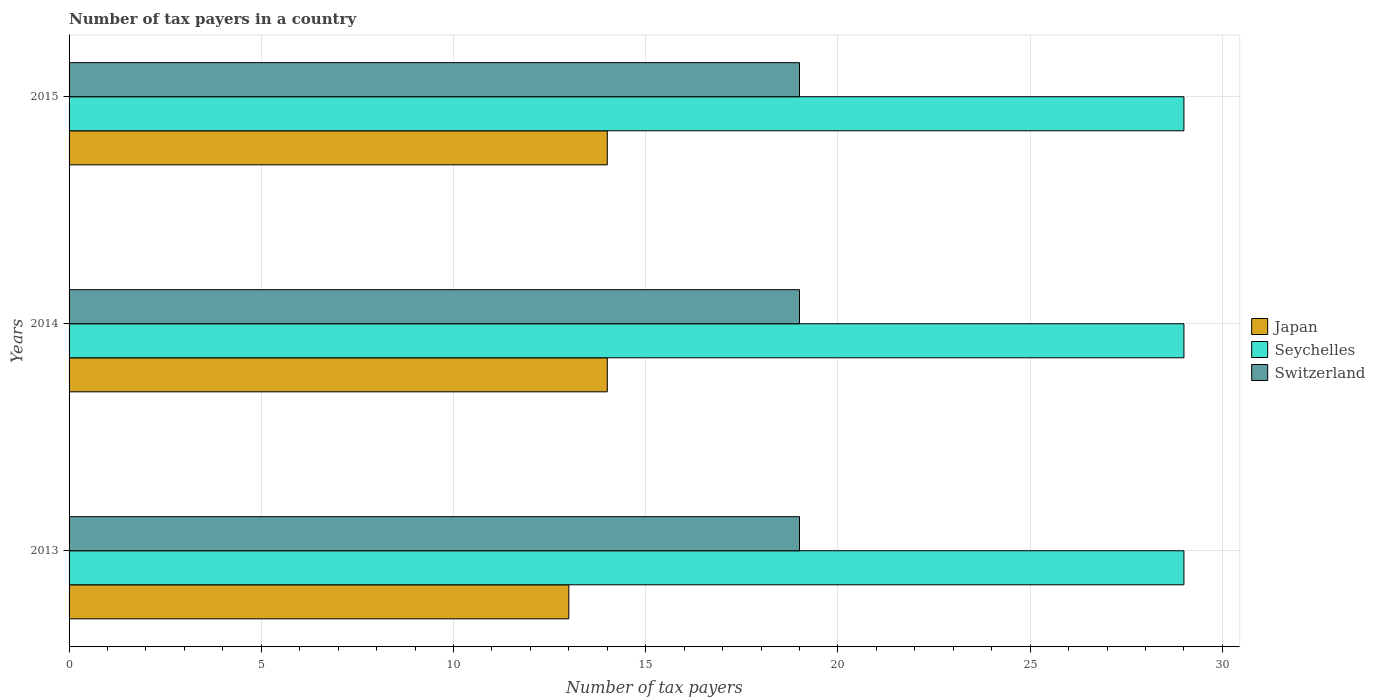Are the number of bars on each tick of the Y-axis equal?
Offer a very short reply. Yes. How many bars are there on the 2nd tick from the top?
Keep it short and to the point. 3. What is the label of the 3rd group of bars from the top?
Keep it short and to the point. 2013. What is the number of tax payers in in Switzerland in 2014?
Ensure brevity in your answer.  19. Across all years, what is the maximum number of tax payers in in Seychelles?
Provide a short and direct response. 29. Across all years, what is the minimum number of tax payers in in Japan?
Make the answer very short. 13. In which year was the number of tax payers in in Seychelles maximum?
Keep it short and to the point. 2013. What is the total number of tax payers in in Switzerland in the graph?
Offer a very short reply. 57. What is the difference between the number of tax payers in in Seychelles in 2013 and that in 2014?
Offer a terse response. 0. What is the difference between the number of tax payers in in Japan in 2013 and the number of tax payers in in Switzerland in 2015?
Keep it short and to the point. -6. What is the average number of tax payers in in Japan per year?
Your answer should be compact. 13.67. In how many years, is the number of tax payers in in Seychelles greater than 16 ?
Give a very brief answer. 3. What is the ratio of the number of tax payers in in Switzerland in 2013 to that in 2014?
Your answer should be very brief. 1. Is the number of tax payers in in Switzerland in 2013 less than that in 2014?
Provide a short and direct response. No. In how many years, is the number of tax payers in in Seychelles greater than the average number of tax payers in in Seychelles taken over all years?
Give a very brief answer. 0. What does the 1st bar from the top in 2014 represents?
Give a very brief answer. Switzerland. What does the 3rd bar from the bottom in 2014 represents?
Your response must be concise. Switzerland. Are all the bars in the graph horizontal?
Offer a very short reply. Yes. How many years are there in the graph?
Give a very brief answer. 3. Are the values on the major ticks of X-axis written in scientific E-notation?
Ensure brevity in your answer.  No. Does the graph contain any zero values?
Your answer should be very brief. No. Does the graph contain grids?
Provide a short and direct response. Yes. Where does the legend appear in the graph?
Your answer should be compact. Center right. How many legend labels are there?
Your response must be concise. 3. How are the legend labels stacked?
Offer a terse response. Vertical. What is the title of the graph?
Keep it short and to the point. Number of tax payers in a country. What is the label or title of the X-axis?
Offer a very short reply. Number of tax payers. What is the Number of tax payers of Japan in 2013?
Your answer should be compact. 13. What is the Number of tax payers of Japan in 2014?
Provide a short and direct response. 14. What is the Number of tax payers in Seychelles in 2014?
Ensure brevity in your answer.  29. Across all years, what is the maximum Number of tax payers of Seychelles?
Keep it short and to the point. 29. Across all years, what is the maximum Number of tax payers in Switzerland?
Provide a succinct answer. 19. Across all years, what is the minimum Number of tax payers of Seychelles?
Offer a terse response. 29. Across all years, what is the minimum Number of tax payers of Switzerland?
Keep it short and to the point. 19. What is the total Number of tax payers in Seychelles in the graph?
Make the answer very short. 87. What is the total Number of tax payers of Switzerland in the graph?
Ensure brevity in your answer.  57. What is the difference between the Number of tax payers in Japan in 2013 and that in 2014?
Offer a terse response. -1. What is the difference between the Number of tax payers in Switzerland in 2013 and that in 2014?
Your response must be concise. 0. What is the difference between the Number of tax payers of Seychelles in 2013 and that in 2015?
Give a very brief answer. 0. What is the difference between the Number of tax payers in Japan in 2013 and the Number of tax payers in Switzerland in 2014?
Make the answer very short. -6. What is the difference between the Number of tax payers in Japan in 2013 and the Number of tax payers in Seychelles in 2015?
Ensure brevity in your answer.  -16. What is the difference between the Number of tax payers in Japan in 2013 and the Number of tax payers in Switzerland in 2015?
Ensure brevity in your answer.  -6. What is the difference between the Number of tax payers in Japan in 2014 and the Number of tax payers in Seychelles in 2015?
Keep it short and to the point. -15. What is the difference between the Number of tax payers in Japan in 2014 and the Number of tax payers in Switzerland in 2015?
Your answer should be compact. -5. What is the difference between the Number of tax payers in Seychelles in 2014 and the Number of tax payers in Switzerland in 2015?
Your answer should be compact. 10. What is the average Number of tax payers of Japan per year?
Your answer should be compact. 13.67. What is the average Number of tax payers in Seychelles per year?
Keep it short and to the point. 29. In the year 2013, what is the difference between the Number of tax payers in Japan and Number of tax payers in Switzerland?
Provide a short and direct response. -6. In the year 2013, what is the difference between the Number of tax payers of Seychelles and Number of tax payers of Switzerland?
Your answer should be compact. 10. In the year 2014, what is the difference between the Number of tax payers in Japan and Number of tax payers in Seychelles?
Provide a short and direct response. -15. In the year 2014, what is the difference between the Number of tax payers of Japan and Number of tax payers of Switzerland?
Make the answer very short. -5. In the year 2015, what is the difference between the Number of tax payers in Japan and Number of tax payers in Switzerland?
Offer a very short reply. -5. In the year 2015, what is the difference between the Number of tax payers of Seychelles and Number of tax payers of Switzerland?
Your answer should be very brief. 10. What is the ratio of the Number of tax payers of Seychelles in 2013 to that in 2014?
Your answer should be very brief. 1. What is the ratio of the Number of tax payers of Switzerland in 2013 to that in 2015?
Make the answer very short. 1. What is the ratio of the Number of tax payers in Switzerland in 2014 to that in 2015?
Ensure brevity in your answer.  1. What is the difference between the highest and the second highest Number of tax payers in Japan?
Your answer should be compact. 0. What is the difference between the highest and the second highest Number of tax payers in Seychelles?
Offer a terse response. 0. What is the difference between the highest and the second highest Number of tax payers of Switzerland?
Give a very brief answer. 0. What is the difference between the highest and the lowest Number of tax payers in Japan?
Provide a short and direct response. 1. What is the difference between the highest and the lowest Number of tax payers in Seychelles?
Provide a succinct answer. 0. 